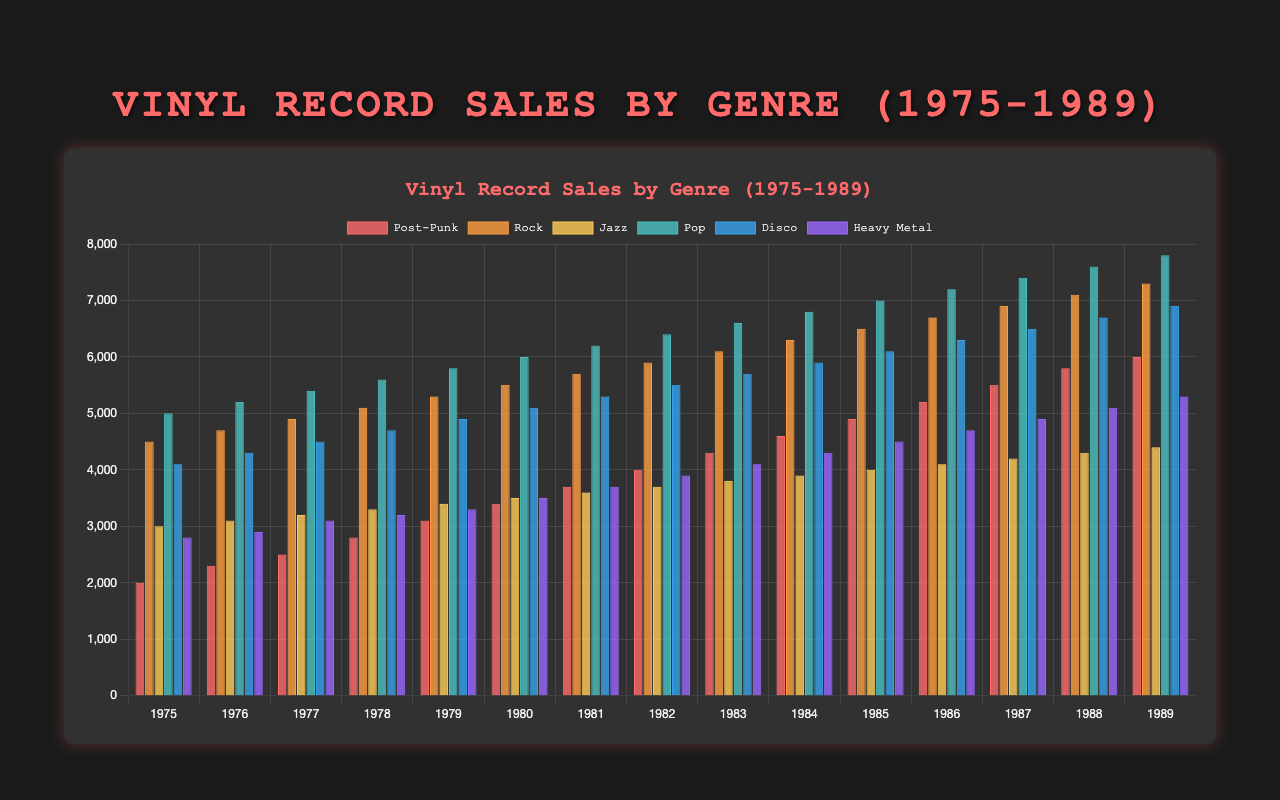What genre had the highest vinyl sales in 1980? To find the answer, locate the bar for 1980 and then identify which genre has the tallest bar. The data suggests Pop had the highest sales.
Answer: Pop How did Post-Punk vinyl sales change from 1975 to 1989? Look at the height of the bars for Post-Punk from 1975 through 1989. Notice the increase from 2000 in 1975 to 6000 in 1989.
Answer: They increased Which genre saw the greatest increase in sales between 1975 and 1989? Calculate the difference in sales from 1975 to 1989 for each genre. The differences are: Post-Punk (4000), Rock (2800), Jazz (1400), Pop (2800), Disco (2800), Heavy Metal (2500). Post-Punk has the greatest increase at 4000.
Answer: Post-Punk What was the average vinyl sales for Jazz in the years 1980-1985? Find sales data for Jazz for each year from 1980 to 1985: 3500, 3600, 3700, 3800, 3900, 4000. The sum = 22500. The average: 22500/6 = 3750.
Answer: 3750 In which year did Heavy Metal see the smallest sales, and what was the amount? Locate the shortest bar for Heavy Metal across all years. The shortest bar is 1975, with sales of 2800.
Answer: 1975, 2800 Which year had the highest total vinyl sales across all genres? Sum the sales for each year and find the highest total. 1989 had the highest total sales (6000 + 7300 + 4400 + 7800 + 6900 + 5300 = 37700).
Answer: 1989 Of the genres Rock and Disco, which had a higher average sales from 1975 to 1989? Calculate average sales for Rock (sum of sales/15) and for Disco (sum of sales/15). Rock: 67600/15 ≈ 4507; Disco: 71600/15 ≈ 4773; Disco has a slightly higher average.
Answer: Disco What was the largest difference in vinyl sales between any two genres in a single year? Compare the sales for each pair of genres for every year and find the maximum difference. In 1989: Pop (7800) - Post-Punk (6000) = 1800.
Answer: 1800 In what year did Pop overtake Post-Punk in vinyl sales, and by how much? Identify the first year where Pop sales exceed Post-Punk sales. Sales for Pop overtook Post-Punk in 1975; 5000 (Pop) - 2000 (Post-Punk) = 3000.
Answer: 1975, 3000 Which genre had the most consistent sales growth (sales increase each year) from 1975 to 1989? Identify the genre with increasing sales every year. Post-Punk sales increased every year from 2000 in 1975 to 6000 in 1989.
Answer: Post-Punk 